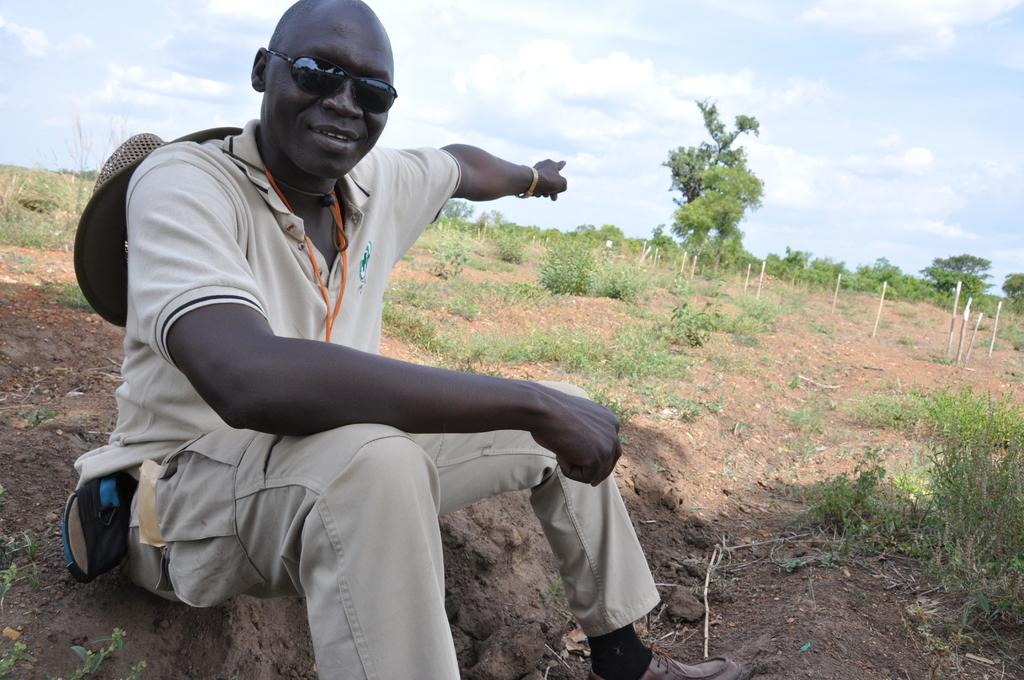Who is present in the image? There is a man in the image. What is the man wearing on his face? The man is wearing goggles. What position is the man in? The man is sitting on the ground. What type of vegetation is on the ground in the image? There is grass on the ground in the image. What can be seen in the background of the image? There are trees in the background of the image. What is visible at the top of the image? The sky is visible at the top of the image. What type of soap is the baby using in the image? There is no baby or soap present in the image; it features a man sitting on the ground with goggles. 